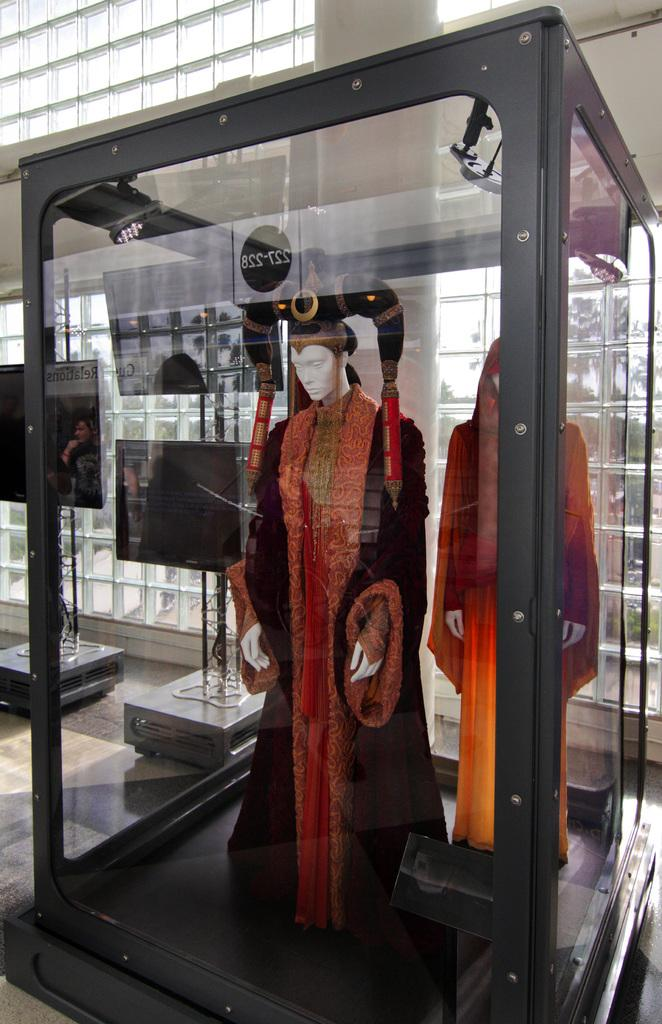How many mannequins are in the image? There are two mannequins in the image. What are the mannequins wearing? The mannequins are wearing dresses. Where are the mannequins located? The mannequins are inside a glass box. What can be seen in the background of the image? There is a wall in the background of the image. Can you see the moon in the image? No, the moon is not visible in the image. 